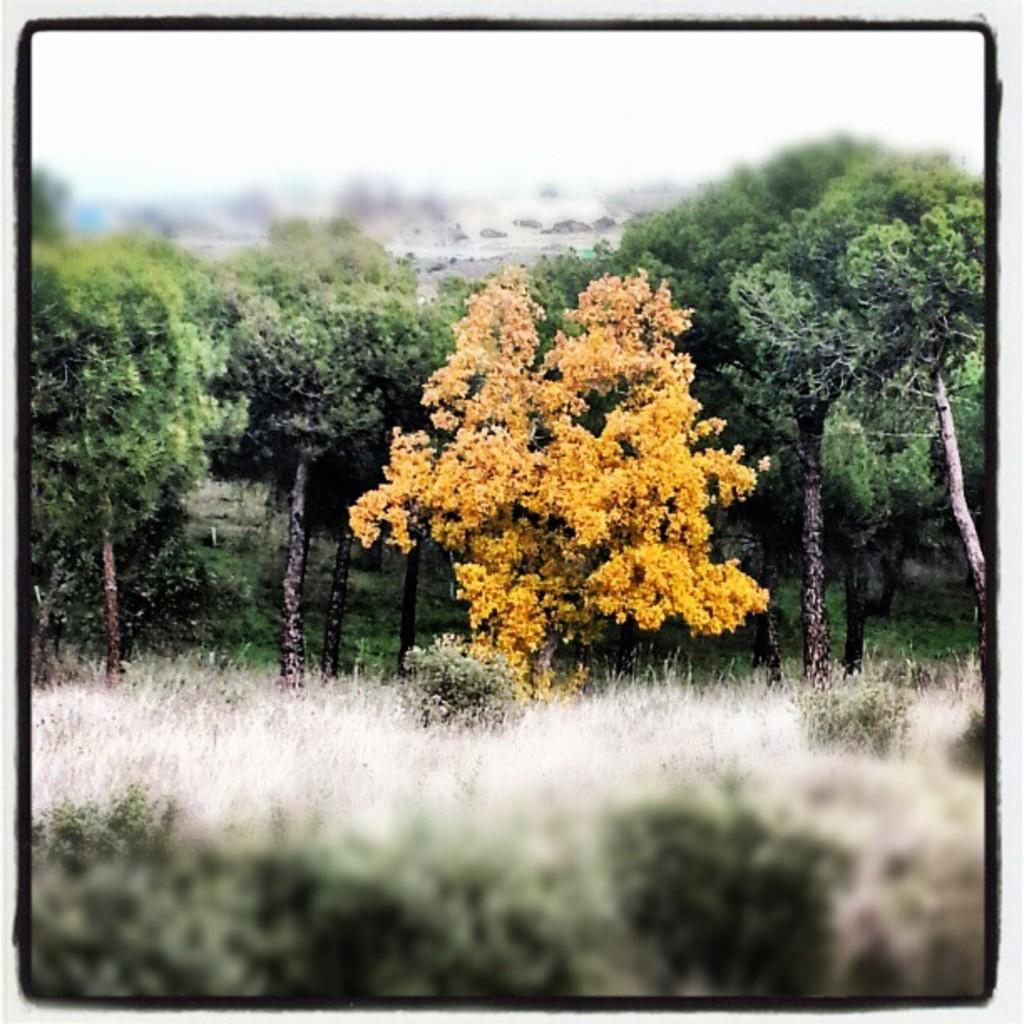What type of vegetation can be seen in the image? There are many trees, plants, and grass in the image. What is the appearance of the edges of the image? The borders of the image are black. How is the view in the top and bottom of the image? The top and bottom of the image have a blurred view. What type of education can be seen in the image? There is no reference to education in the image; it primarily features vegetation and the image's borders and view. What type of tooth is visible in the image? There is no tooth present in the image. 